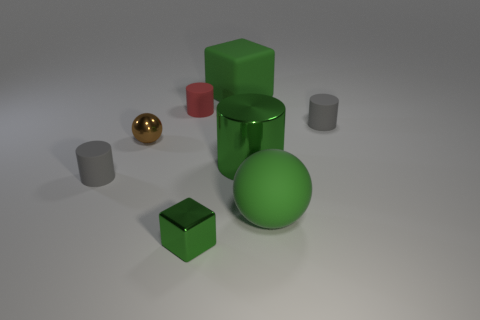How many green blocks must be subtracted to get 1 green blocks? 1 Subtract 1 cylinders. How many cylinders are left? 3 Add 1 green matte spheres. How many objects exist? 9 Subtract all blocks. How many objects are left? 6 Subtract all large red blocks. Subtract all small gray rubber cylinders. How many objects are left? 6 Add 7 gray cylinders. How many gray cylinders are left? 9 Add 4 metal objects. How many metal objects exist? 7 Subtract 0 purple cylinders. How many objects are left? 8 